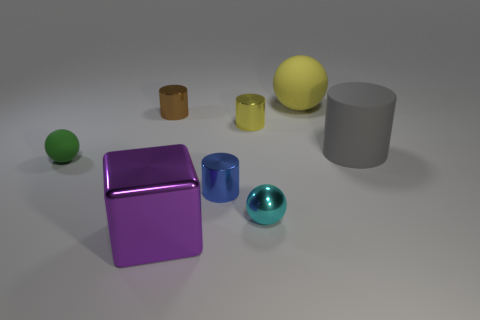There is a rubber object in front of the gray rubber thing; what is its size?
Offer a terse response. Small. There is a green sphere; is its size the same as the metallic cylinder left of the blue thing?
Give a very brief answer. Yes. What is the color of the tiny metal cylinder on the left side of the large thing in front of the large gray thing?
Offer a terse response. Brown. How many other objects are there of the same color as the tiny matte sphere?
Ensure brevity in your answer.  0. How big is the purple metal cube?
Make the answer very short. Large. Is the number of small brown metal things that are right of the tiny brown thing greater than the number of large matte things that are on the left side of the small shiny ball?
Offer a very short reply. No. There is a sphere behind the green sphere; what number of objects are on the left side of it?
Keep it short and to the point. 6. Is the shape of the big rubber object that is to the right of the yellow sphere the same as  the green thing?
Your answer should be compact. No. There is a brown thing that is the same shape as the blue metallic thing; what material is it?
Your response must be concise. Metal. How many yellow rubber balls are the same size as the yellow rubber object?
Provide a short and direct response. 0. 